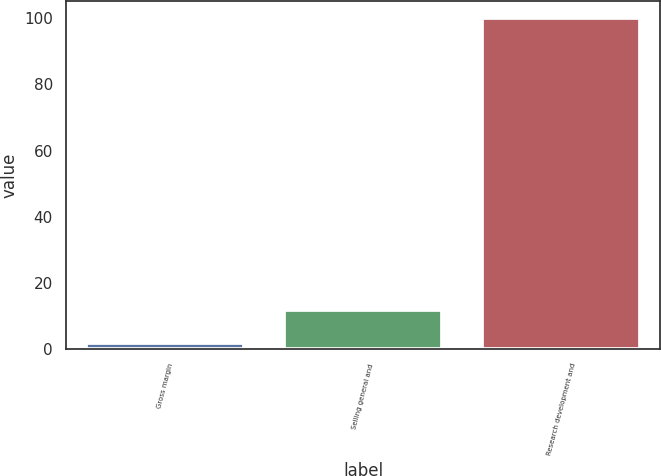Convert chart to OTSL. <chart><loc_0><loc_0><loc_500><loc_500><bar_chart><fcel>Gross margin<fcel>Selling general and<fcel>Research development and<nl><fcel>2<fcel>11.8<fcel>100<nl></chart> 